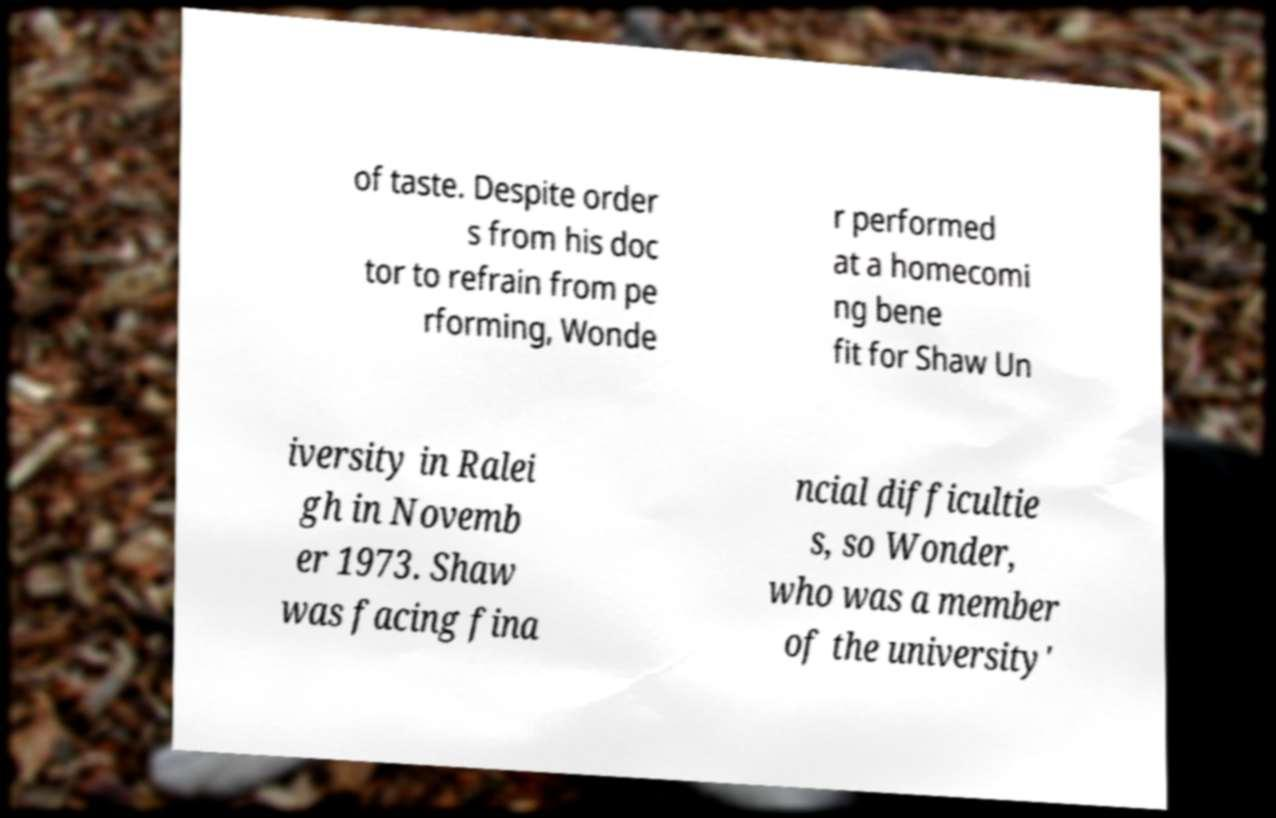Please identify and transcribe the text found in this image. of taste. Despite order s from his doc tor to refrain from pe rforming, Wonde r performed at a homecomi ng bene fit for Shaw Un iversity in Ralei gh in Novemb er 1973. Shaw was facing fina ncial difficultie s, so Wonder, who was a member of the university' 